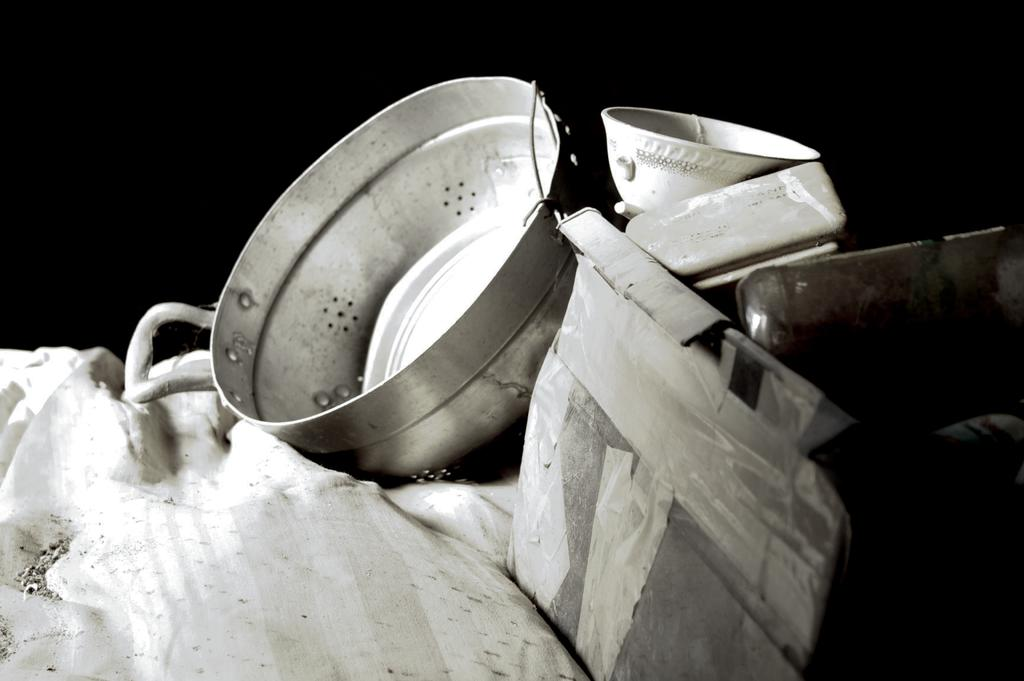What is the color scheme of the image? The image is black and white. What type of object can be seen in the image? There is a cloth in the image. What other objects are present in the image? There is a vessel and a bowl in the image, along with other items. How would you describe the background of the image? The background of the image is dark. What type of parcel is being delivered in the image? There is no parcel present in the image. Can you hear a whistle in the image? There is no sound in the image, so it is impossible to hear a whistle. 